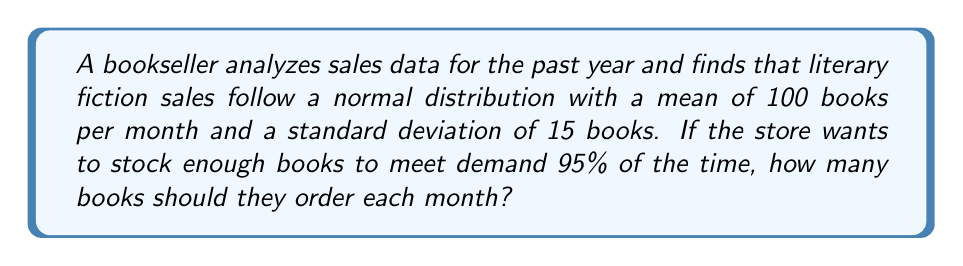Help me with this question. To solve this problem, we need to use the properties of the normal distribution and the concept of z-scores.

Step 1: Identify the given information
- Mean ($\mu$) = 100 books per month
- Standard deviation ($\sigma$) = 15 books
- Desired confidence level = 95%

Step 2: Determine the z-score for 95% confidence
For a 95% confidence level, we need the z-score that corresponds to the 97.5th percentile (as we want to cover both tails of the distribution). This z-score is approximately 1.96.

Step 3: Use the z-score formula to calculate the number of books
The formula for z-score is:

$$ z = \frac{X - \mu}{\sigma} $$

Where X is the value we're looking for. Rearranging the formula:

$$ X = \mu + z\sigma $$

Step 4: Plug in the values
$$ X = 100 + (1.96 \times 15) $$

Step 5: Calculate the result
$$ X = 100 + 29.4 = 129.4 $$

Step 6: Round up to the nearest whole number
Since we can't order partial books, we round up to 130 books.
Answer: 130 books 